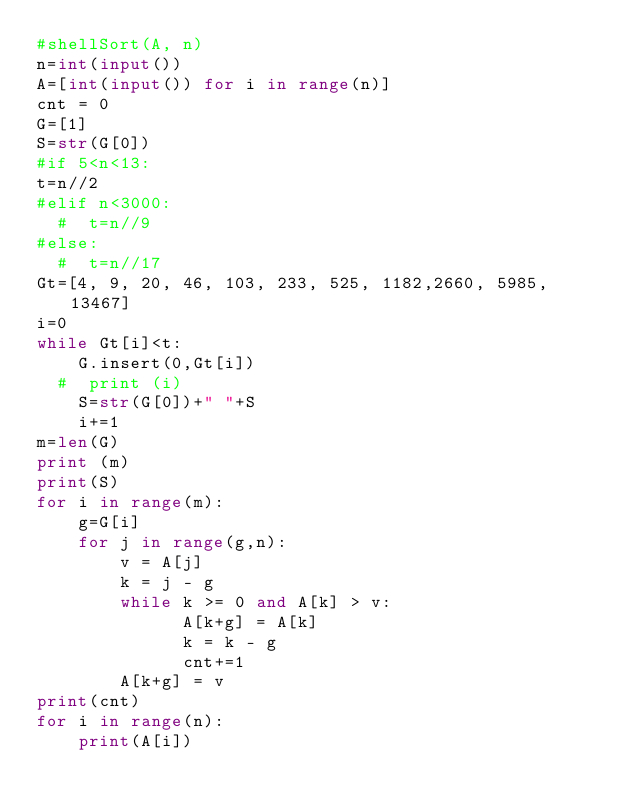<code> <loc_0><loc_0><loc_500><loc_500><_Python_>#shellSort(A, n)
n=int(input())
A=[int(input()) for i in range(n)]
cnt = 0
G=[1]
S=str(G[0])
#if 5<n<13:
t=n//2
#elif n<3000:
  #  t=n//9
#else:
  #  t=n//17
Gt=[4, 9, 20, 46, 103, 233, 525, 1182,2660, 5985, 13467]
i=0
while Gt[i]<t:
    G.insert(0,Gt[i])
  #  print (i)
    S=str(G[0])+" "+S
    i+=1
m=len(G)
print (m)
print(S)
for i in range(m):
    g=G[i]
    for j in range(g,n):
        v = A[j]
        k = j - g
        while k >= 0 and A[k] > v:
              A[k+g] = A[k]
              k = k - g
              cnt+=1
        A[k+g] = v 
print(cnt)
for i in range(n):
    print(A[i])</code> 